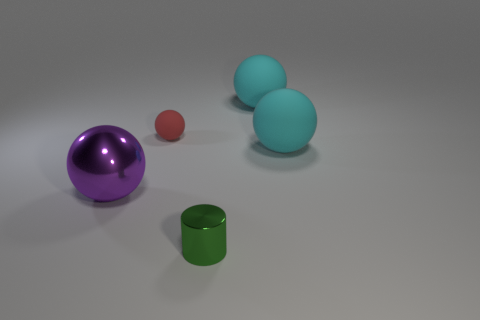What number of objects are either metal objects on the left side of the small sphere or purple metal objects that are behind the green metal object?
Keep it short and to the point. 1. Are there an equal number of cyan things that are left of the cylinder and brown metallic cubes?
Offer a terse response. Yes. There is a shiny thing that is behind the green shiny thing; is its size the same as the metallic thing that is in front of the purple sphere?
Make the answer very short. No. What number of other objects are the same size as the red rubber thing?
Your answer should be very brief. 1. Are there any large cyan things behind the cyan object behind the big matte sphere in front of the tiny rubber sphere?
Your answer should be compact. No. Are there any other things of the same color as the small metallic cylinder?
Your answer should be very brief. No. There is a matte ball that is to the left of the tiny green metallic cylinder; what is its size?
Provide a succinct answer. Small. How big is the shiny thing that is right of the tiny thing on the left side of the tiny object that is in front of the tiny ball?
Make the answer very short. Small. There is a matte ball that is in front of the small thing that is behind the big purple sphere; what is its color?
Provide a short and direct response. Cyan. There is a big purple thing that is the same shape as the tiny rubber object; what is its material?
Provide a succinct answer. Metal. 